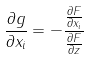Convert formula to latex. <formula><loc_0><loc_0><loc_500><loc_500>\frac { \partial g } { \partial x _ { i } } = - \frac { \frac { \partial F } { \partial x _ { i } } } { \frac { \partial F } { \partial z } }</formula> 